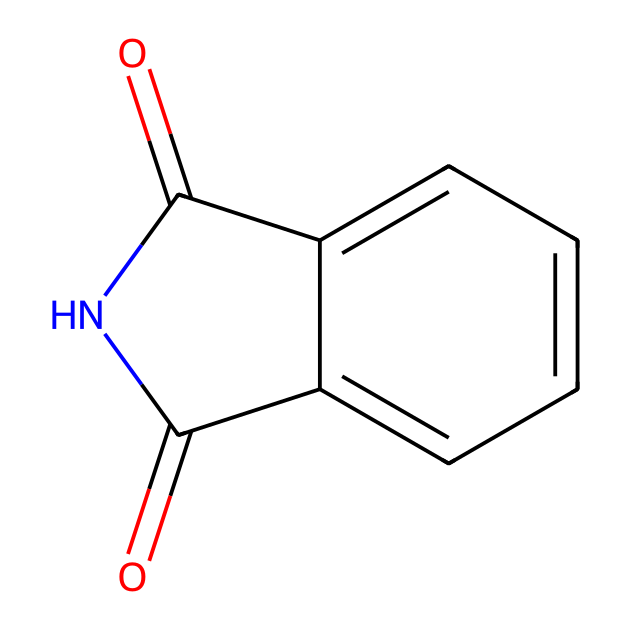How many nitrogen atoms are in the structure? By examining the SMILES representation, we see there is one 'N' in the sequence, indicating the presence of a single nitrogen atom.
Answer: one What type of functional groups are present in phthalimide? The structure includes carboxamide groups (indicated by the 'C(=O)N' sequence) which are characteristic of imides.
Answer: carboxamide What is the total number of aromatic rings in this compound? The chemical structure features one benzene-like structure as shown by 'c2ccccc2', indicating a single aromatic ring in the entire molecule.
Answer: one What is the molecular formula for phthalimide? Counting all the components represented in the chemical structure, we find it consists of C8, H5, N1, O2, leading to the molecular formula C8H5NO2.
Answer: C8H5NO2 How does the presence of the nitrogen in phthalimide influence its reactivity? The nitrogen atom contributes to the electron-withdrawing character of the amide group, enhancing the reactivity by making adjacent carbonyl carbons more electrophilic.
Answer: increases reactivity What distinguishes phthalimide from other imides? Phthalimide features a fused aromatic ring structure and specific steric and electronic properties due to its attachment to the phthalic acid derivative, making it unique among imides.
Answer: fused aromatic structure How does the geometry around the nitrogen atom affect phthalimide's properties? The nitrogen in the imide is typically planar due to sp2 hybridization, which plays a role in stabilizing the structure and determining interactions with other molecules.
Answer: planar geometry 